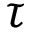<formula> <loc_0><loc_0><loc_500><loc_500>\tau</formula> 